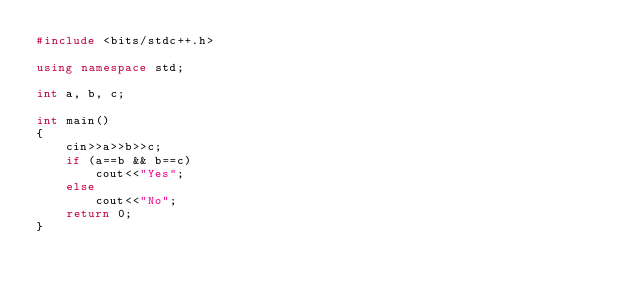<code> <loc_0><loc_0><loc_500><loc_500><_C++_>#include <bits/stdc++.h>

using namespace std;

int a, b, c;

int main()
{
    cin>>a>>b>>c;
    if (a==b && b==c)
        cout<<"Yes";
    else
        cout<<"No";
    return 0;
}</code> 